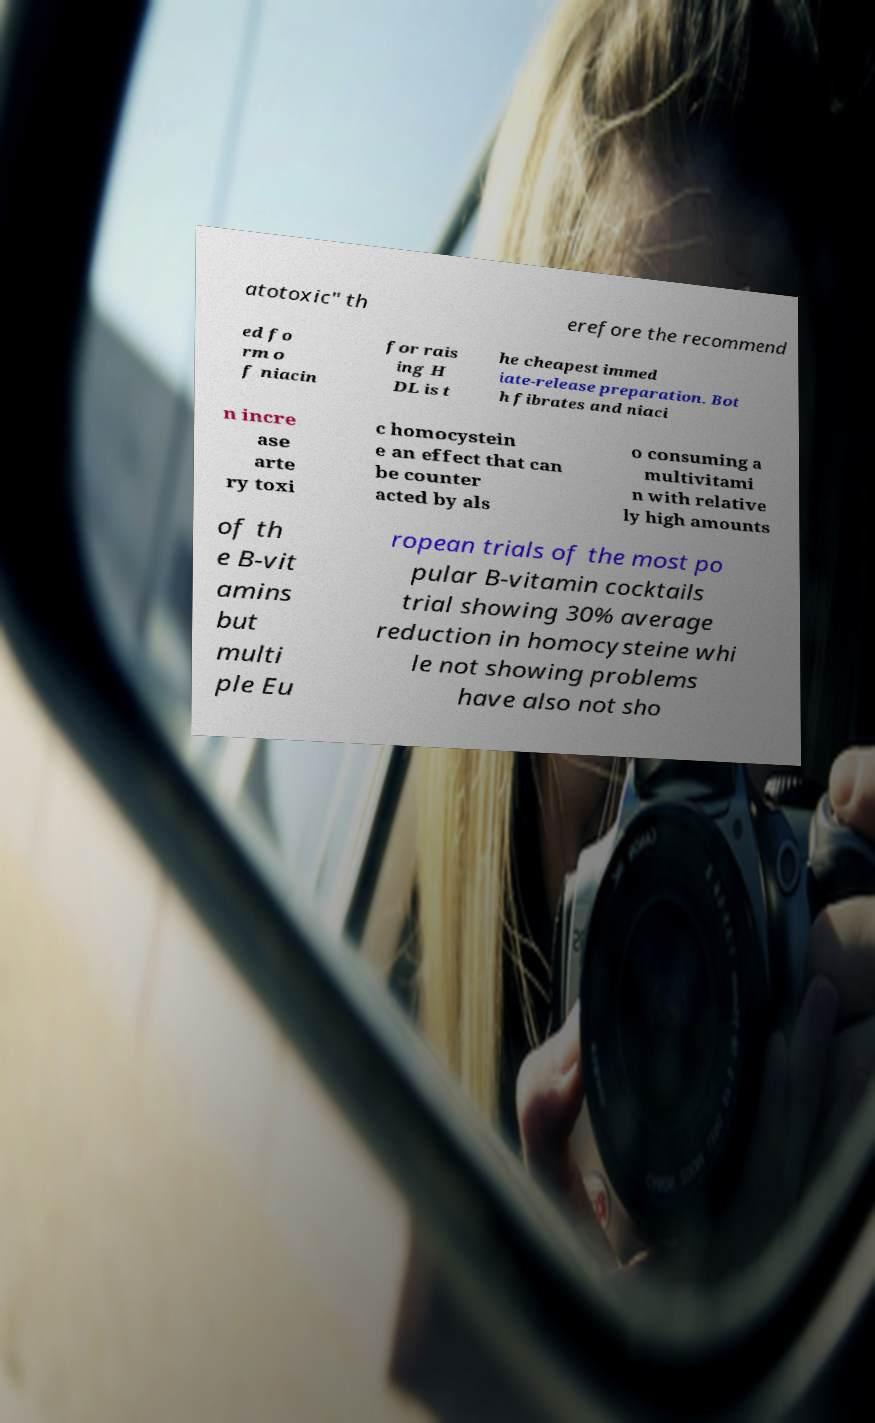Could you assist in decoding the text presented in this image and type it out clearly? atotoxic" th erefore the recommend ed fo rm o f niacin for rais ing H DL is t he cheapest immed iate-release preparation. Bot h fibrates and niaci n incre ase arte ry toxi c homocystein e an effect that can be counter acted by als o consuming a multivitami n with relative ly high amounts of th e B-vit amins but multi ple Eu ropean trials of the most po pular B-vitamin cocktails trial showing 30% average reduction in homocysteine whi le not showing problems have also not sho 